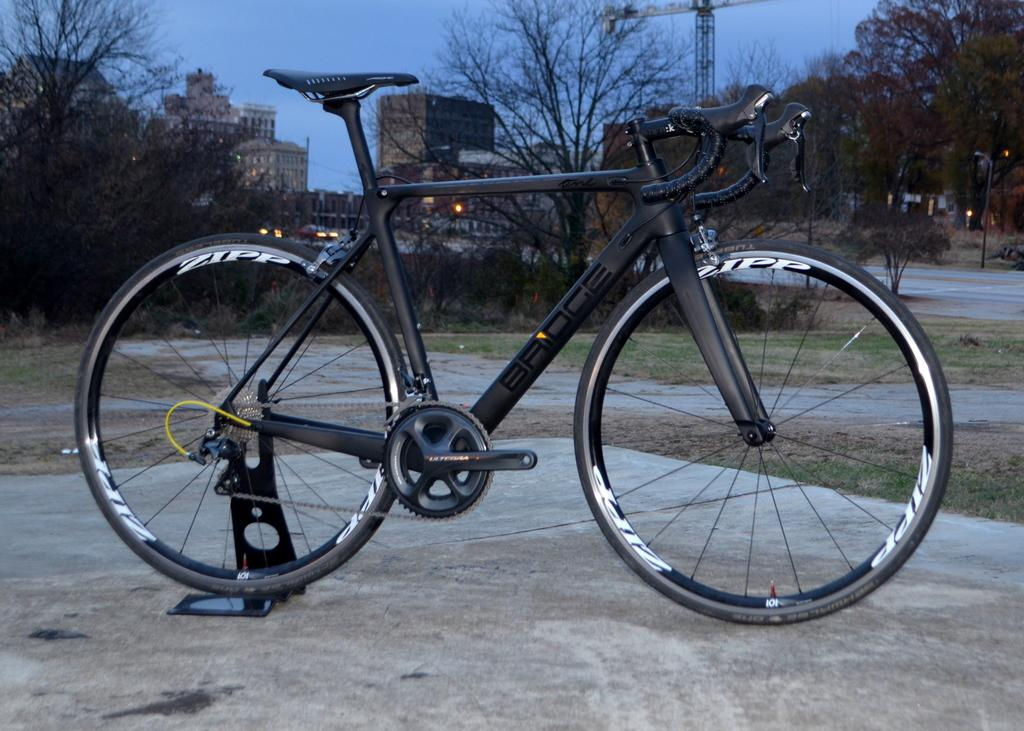What is the main object in the middle of the image? There is a bicycle parked in the middle of the image. Where is the bicycle located? The bicycle is on a road. What can be seen in the background of the image? There are vehicles, trees, and buildings in the background of the image. What is visible in the sky? There are clouds visible in the sky. What type of star is visible in the image? There is no star visible in the image; only clouds are visible in the sky. 